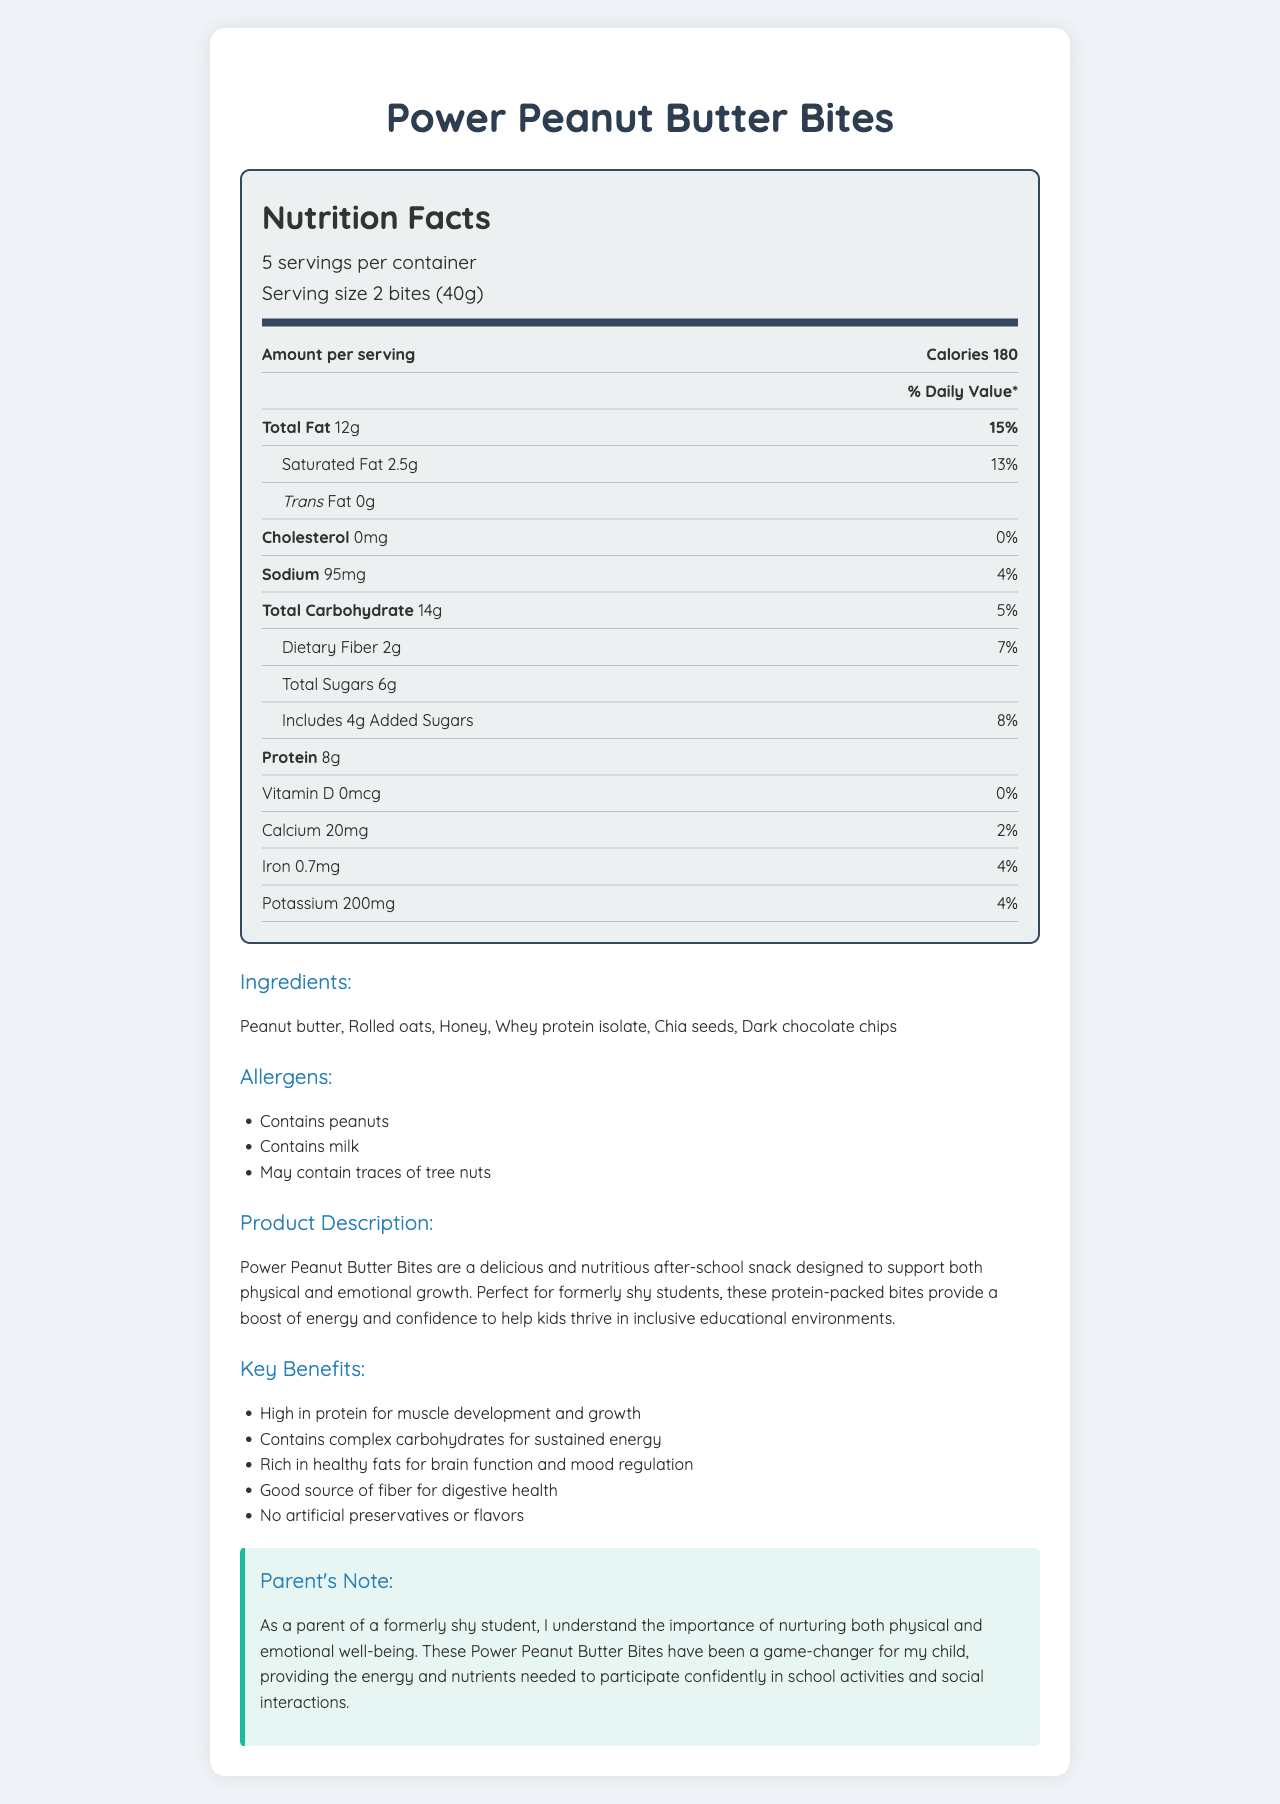What is the serving size for Power Peanut Butter Bites? The serving size is mentioned as "2 bites (40g)" at the beginning of the document.
Answer: 2 bites (40g) How many calories are there per serving? Under the "Amount per serving" section, it is stated that each serving contains 180 calories.
Answer: 180 What percentage of the daily value for total fat is in one serving of Power Peanut Butter Bites? The document states that the total fat is 12g and this represents 15% of the daily value.
Answer: 15% Does the product contain any trans fat? The document clearly states that the trans fat amount is 0g.
Answer: No, it has 0g trans fat List the main ingredients of Power Peanut Butter Bites. The ingredients are listed clearly in the document.
Answer: Peanut butter, Rolled oats, Honey, Whey protein isolate, Chia seeds, Dark chocolate chips Which of the following is a key benefit of Power Peanut Butter Bites? I. High in protein II. Contains artificial preservatives III. Good source of fiber The document states that the bites are high in protein and a good source of fiber, but it does not contain artificial preservatives.
Answer: I and III How many servings are in one container of Power Peanut Butter Bites? A. 3 B. 4 C. 5 D. 6 The document mentions that there are 5 servings per container.
Answer: C What is the amount of dietary fiber per serving? The document specifies that each serving contains 2g of dietary fiber.
Answer: 2g Do Power Peanut Butter Bites contain any added sugars? The document mentions that there are 4g of added sugars per serving.
Answer: Yes, 4g of added sugars Are Power Peanut Butter Bites suitable for someone with a peanut allergy? The ingredients list includes peanuts and the allergens section also notes that it contains peanuts.
Answer: No Summarize the overall benefits of Power Peanut Butter Bites. The benefits are listed clearly in the document under the "Key Benefits" section.
Answer: Power Peanut Butter Bites are high in protein, rich in healthy fats, contain complex carbohydrates for sustained energy, and are good sources of fiber. They do not contain artificial preservatives or flavors. Can we determine the manufacturing date of Power Peanut Butter Bites from this document? The document does not provide any information about the manufacturing date.
Answer: Cannot be determined 